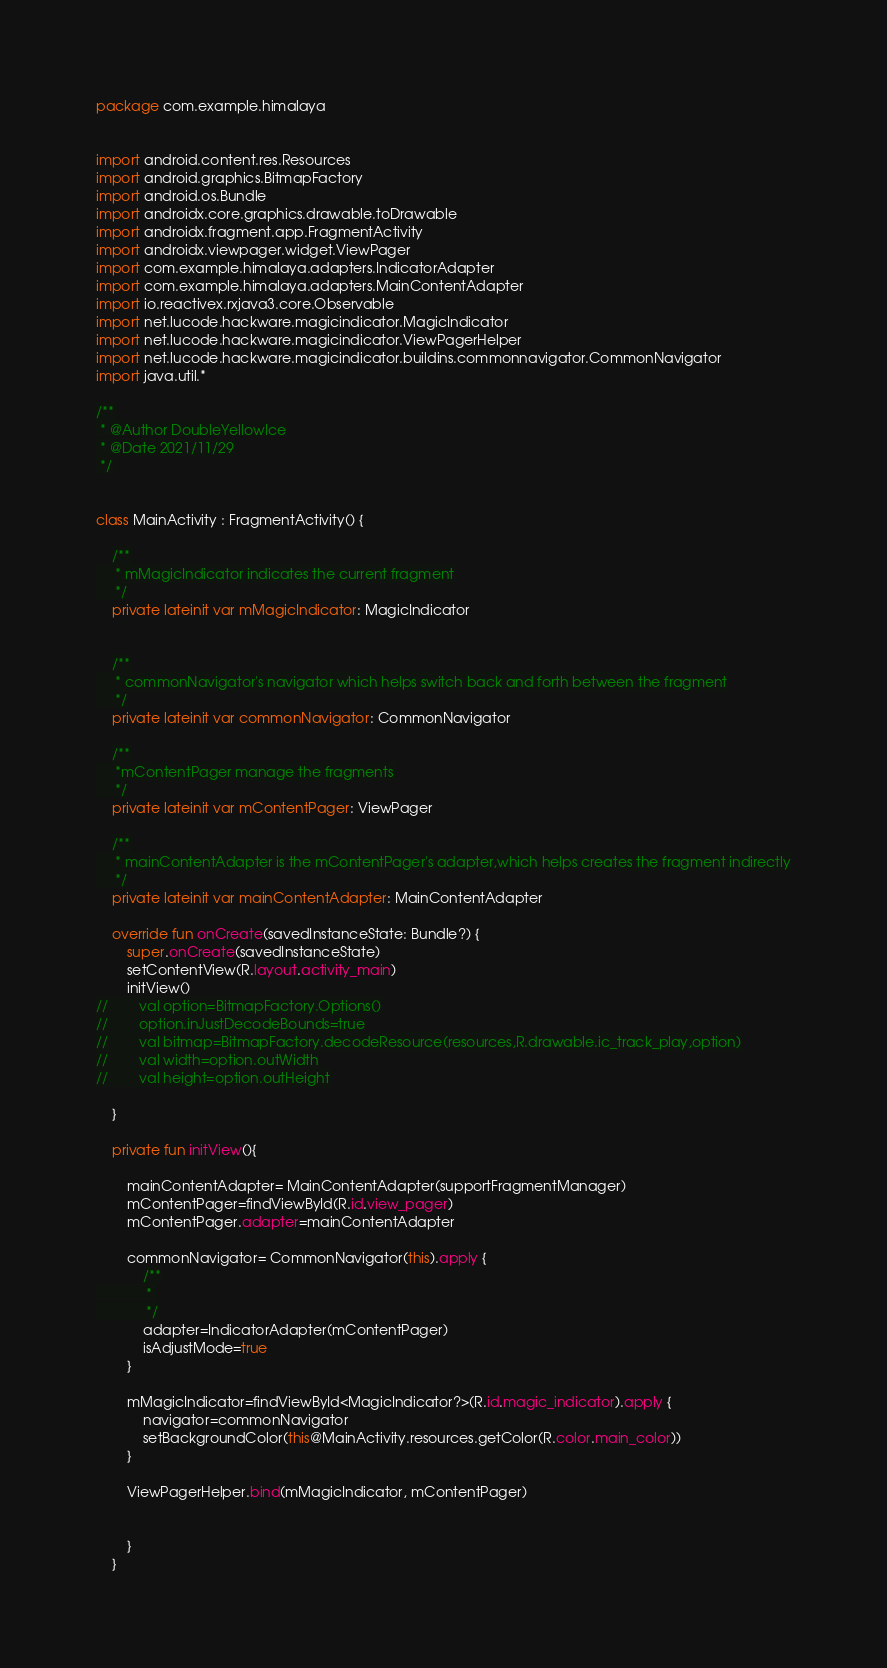<code> <loc_0><loc_0><loc_500><loc_500><_Kotlin_>package com.example.himalaya


import android.content.res.Resources
import android.graphics.BitmapFactory
import android.os.Bundle
import androidx.core.graphics.drawable.toDrawable
import androidx.fragment.app.FragmentActivity
import androidx.viewpager.widget.ViewPager
import com.example.himalaya.adapters.IndicatorAdapter
import com.example.himalaya.adapters.MainContentAdapter
import io.reactivex.rxjava3.core.Observable
import net.lucode.hackware.magicindicator.MagicIndicator
import net.lucode.hackware.magicindicator.ViewPagerHelper
import net.lucode.hackware.magicindicator.buildins.commonnavigator.CommonNavigator
import java.util.*

/**
 * @Author DoubleYellowIce
 * @Date 2021/11/29
 */


class MainActivity : FragmentActivity() {

    /**
     * mMagicIndicator indicates the current fragment
     */
    private lateinit var mMagicIndicator: MagicIndicator


    /**
     * commonNavigator's navigator which helps switch back and forth between the fragment
     */
    private lateinit var commonNavigator: CommonNavigator

    /**
     *mContentPager manage the fragments
     */
    private lateinit var mContentPager: ViewPager

    /**
     * mainContentAdapter is the mContentPager's adapter,which helps creates the fragment indirectly
     */
    private lateinit var mainContentAdapter: MainContentAdapter

    override fun onCreate(savedInstanceState: Bundle?) {
        super.onCreate(savedInstanceState)
        setContentView(R.layout.activity_main)
        initView()
//        val option=BitmapFactory.Options()
//        option.inJustDecodeBounds=true
//        val bitmap=BitmapFactory.decodeResource(resources,R.drawable.ic_track_play,option)
//        val width=option.outWidth
//        val height=option.outHeight

    }

    private fun initView(){

        mainContentAdapter= MainContentAdapter(supportFragmentManager)
        mContentPager=findViewById(R.id.view_pager)
        mContentPager.adapter=mainContentAdapter

        commonNavigator= CommonNavigator(this).apply {
            /**
             * 
             */
            adapter=IndicatorAdapter(mContentPager)
            isAdjustMode=true
        }

        mMagicIndicator=findViewById<MagicIndicator?>(R.id.magic_indicator).apply {
            navigator=commonNavigator
            setBackgroundColor(this@MainActivity.resources.getColor(R.color.main_color))
        }

        ViewPagerHelper.bind(mMagicIndicator, mContentPager)


        }
    }



</code> 